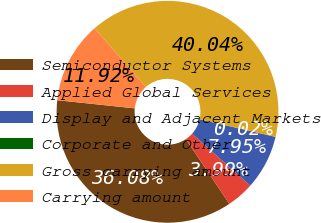Convert chart. <chart><loc_0><loc_0><loc_500><loc_500><pie_chart><fcel>Semiconductor Systems<fcel>Applied Global Services<fcel>Display and Adjacent Markets<fcel>Corporate and Other<fcel>Gross carrying amount<fcel>Carrying amount<nl><fcel>36.08%<fcel>3.99%<fcel>7.95%<fcel>0.02%<fcel>40.04%<fcel>11.92%<nl></chart> 